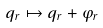Convert formula to latex. <formula><loc_0><loc_0><loc_500><loc_500>q _ { r } \mapsto q _ { r } + \varphi _ { r }</formula> 